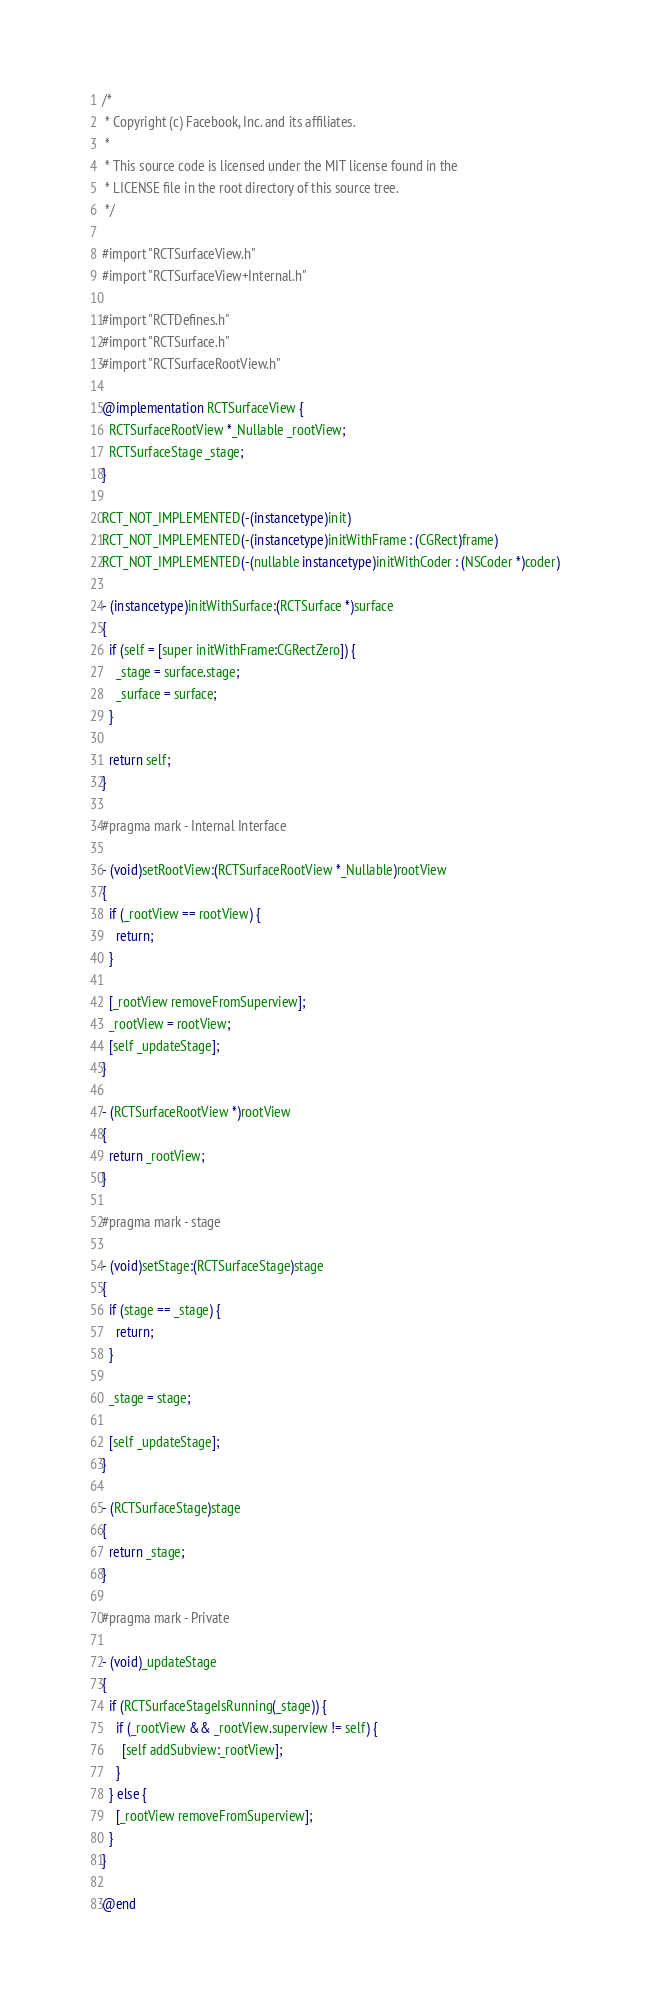<code> <loc_0><loc_0><loc_500><loc_500><_ObjectiveC_>/*
 * Copyright (c) Facebook, Inc. and its affiliates.
 *
 * This source code is licensed under the MIT license found in the
 * LICENSE file in the root directory of this source tree.
 */

#import "RCTSurfaceView.h"
#import "RCTSurfaceView+Internal.h"

#import "RCTDefines.h"
#import "RCTSurface.h"
#import "RCTSurfaceRootView.h"

@implementation RCTSurfaceView {
  RCTSurfaceRootView *_Nullable _rootView;
  RCTSurfaceStage _stage;
}

RCT_NOT_IMPLEMENTED(-(instancetype)init)
RCT_NOT_IMPLEMENTED(-(instancetype)initWithFrame : (CGRect)frame)
RCT_NOT_IMPLEMENTED(-(nullable instancetype)initWithCoder : (NSCoder *)coder)

- (instancetype)initWithSurface:(RCTSurface *)surface
{
  if (self = [super initWithFrame:CGRectZero]) {
    _stage = surface.stage;
    _surface = surface;
  }

  return self;
}

#pragma mark - Internal Interface

- (void)setRootView:(RCTSurfaceRootView *_Nullable)rootView
{
  if (_rootView == rootView) {
    return;
  }

  [_rootView removeFromSuperview];
  _rootView = rootView;
  [self _updateStage];
}

- (RCTSurfaceRootView *)rootView
{
  return _rootView;
}

#pragma mark - stage

- (void)setStage:(RCTSurfaceStage)stage
{
  if (stage == _stage) {
    return;
  }

  _stage = stage;

  [self _updateStage];
}

- (RCTSurfaceStage)stage
{
  return _stage;
}

#pragma mark - Private

- (void)_updateStage
{
  if (RCTSurfaceStageIsRunning(_stage)) {
    if (_rootView && _rootView.superview != self) {
      [self addSubview:_rootView];
    }
  } else {
    [_rootView removeFromSuperview];
  }
}

@end
</code> 